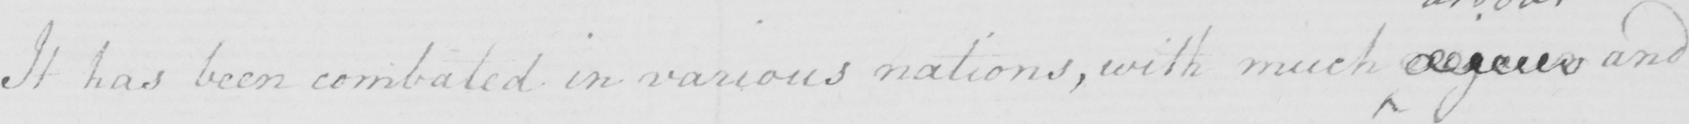What is written in this line of handwriting? It has been combated in various nations , with much  <gap/>  and 